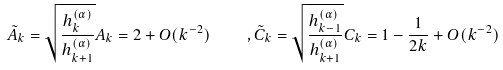Convert formula to latex. <formula><loc_0><loc_0><loc_500><loc_500>\tilde { A } _ { k } = \sqrt { \frac { h _ { k } ^ { ( \alpha ) } } { h _ { k + 1 } ^ { ( \alpha ) } } } A _ { k } = 2 + O ( k ^ { - 2 } ) \quad , \tilde { C } _ { k } = \sqrt { \frac { h _ { k - 1 } ^ { ( \alpha ) } } { h _ { k + 1 } ^ { ( \alpha ) } } } C _ { k } = 1 - \frac { 1 } { 2 k } + O ( k ^ { - 2 } )</formula> 